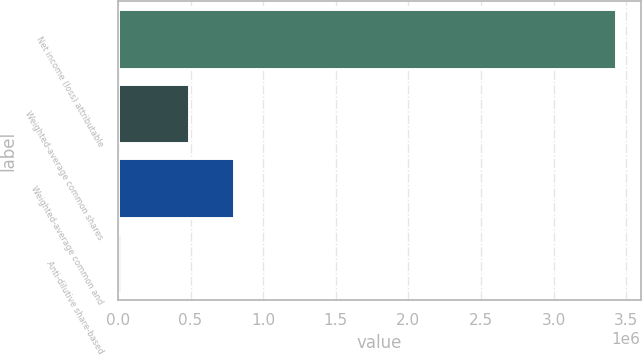<chart> <loc_0><loc_0><loc_500><loc_500><bar_chart><fcel>Net income (loss) attributable<fcel>Weighted-average common shares<fcel>Weighted-average common and<fcel>Anti-dilutive share-based<nl><fcel>3.42775e+06<fcel>488652<fcel>801762<fcel>21886<nl></chart> 